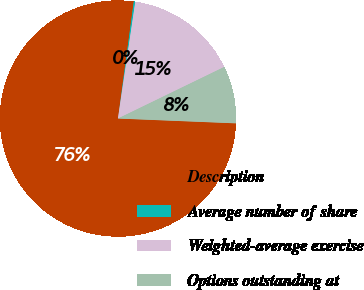Convert chart to OTSL. <chart><loc_0><loc_0><loc_500><loc_500><pie_chart><fcel>Description<fcel>Average number of share<fcel>Weighted-average exercise<fcel>Options outstanding at<nl><fcel>76.49%<fcel>0.21%<fcel>15.46%<fcel>7.84%<nl></chart> 